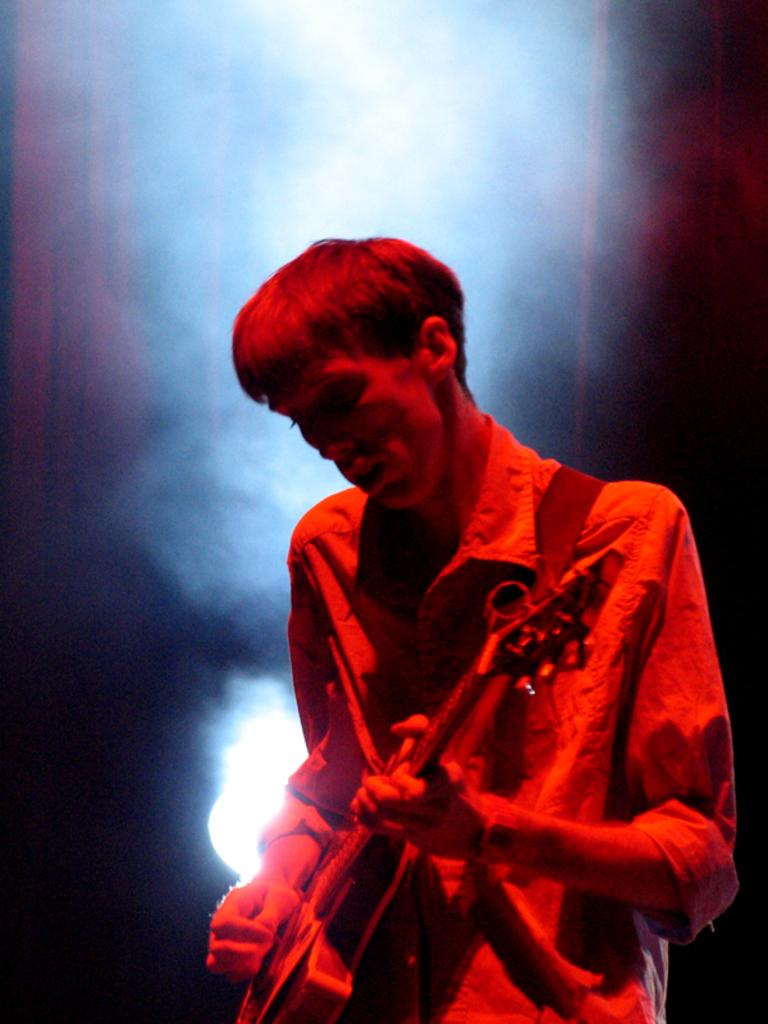What is the person in the image doing? The person is playing a guitar. What can be seen in the background of the image? There is light and smoke in the background of the image. Can you tell me how many trays are visible in the image? There are no trays present in the image. What type of ocean can be seen in the background of the image? There is no ocean present in the image; it features a person playing a guitar with light and smoke in the background. 